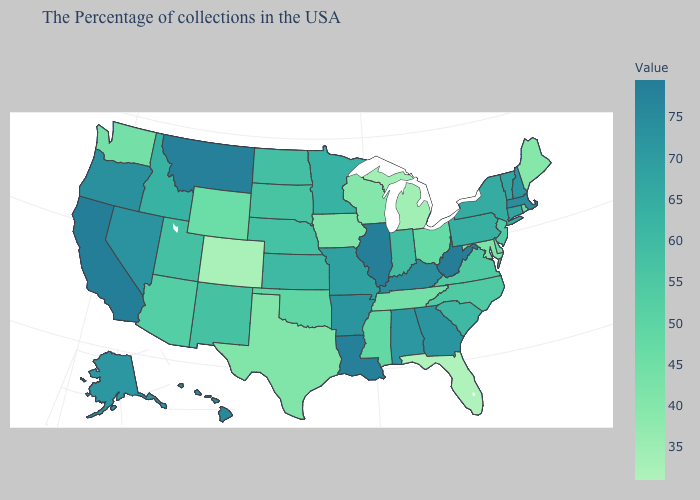Does Washington have a higher value than Michigan?
Answer briefly. Yes. Among the states that border Louisiana , which have the highest value?
Short answer required. Arkansas. Among the states that border Colorado , does Arizona have the lowest value?
Answer briefly. No. Does the map have missing data?
Concise answer only. No. Does Iowa have the lowest value in the USA?
Quick response, please. No. Which states have the highest value in the USA?
Write a very short answer. West Virginia. 